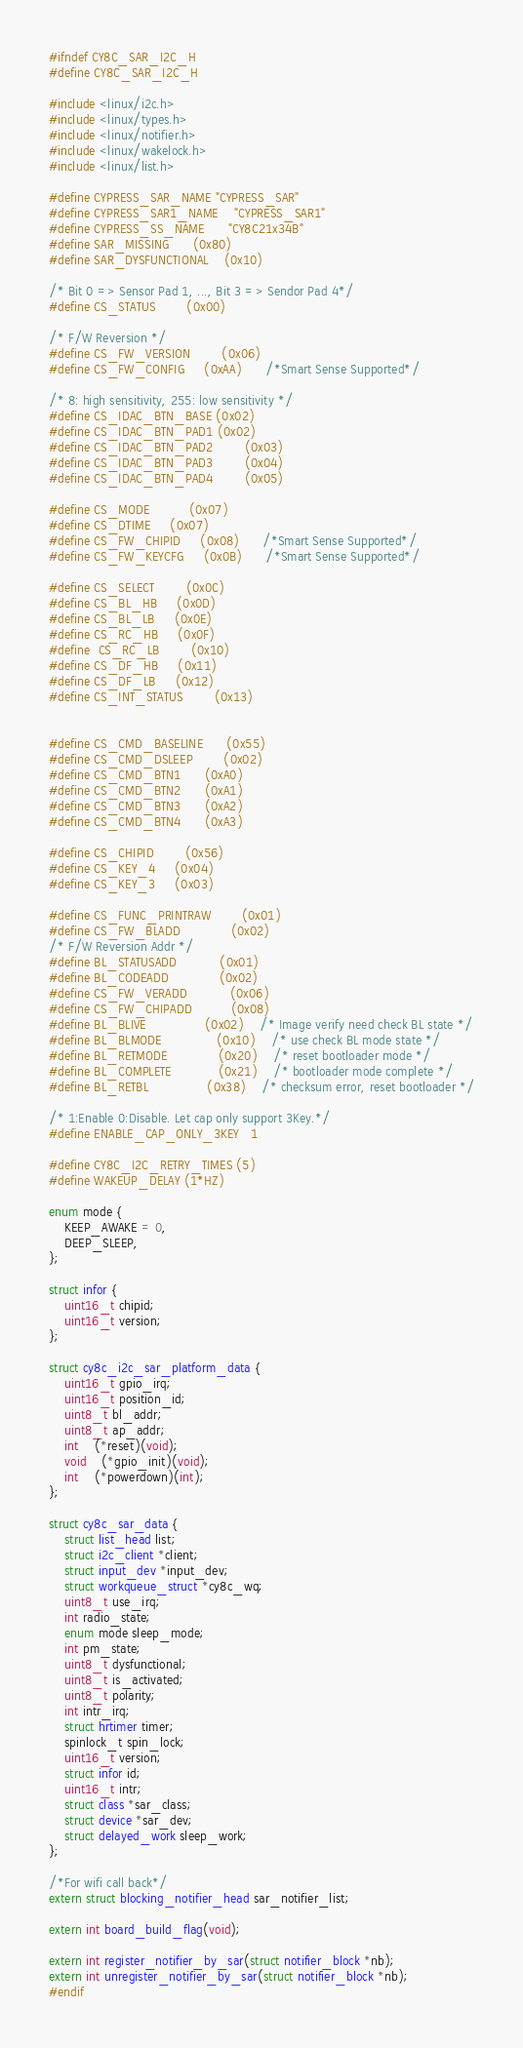Convert code to text. <code><loc_0><loc_0><loc_500><loc_500><_C_>#ifndef CY8C_SAR_I2C_H
#define CY8C_SAR_I2C_H

#include <linux/i2c.h>
#include <linux/types.h>
#include <linux/notifier.h>
#include <linux/wakelock.h>
#include <linux/list.h>

#define CYPRESS_SAR_NAME	"CYPRESS_SAR"
#define CYPRESS_SAR1_NAME	"CYPRESS_SAR1"
#define CYPRESS_SS_NAME		"CY8C21x34B"
#define SAR_MISSING		(0x80)
#define SAR_DYSFUNCTIONAL	(0x10)

/* Bit 0 => Sensor Pad 1, ..., Bit 3 => Sendor Pad 4*/
#define CS_STATUS		(0x00)

/* F/W Reversion */
#define CS_FW_VERSION		(0x06)
#define CS_FW_CONFIG		(0xAA)		/*Smart Sense Supported*/

/* 8: high sensitivity, 255: low sensitivity */
#define CS_IDAC_BTN_BASE	(0x02)
#define CS_IDAC_BTN_PAD1	(0x02)
#define CS_IDAC_BTN_PAD2        (0x03)
#define CS_IDAC_BTN_PAD3        (0x04)
#define CS_IDAC_BTN_PAD4        (0x05)

#define CS_MODE			(0x07)
#define CS_DTIME		(0x07)
#define CS_FW_CHIPID		(0x08)		/*Smart Sense Supported*/
#define CS_FW_KEYCFG		(0x0B)		/*Smart Sense Supported*/

#define CS_SELECT		(0x0C)
#define CS_BL_HB		(0x0D)
#define CS_BL_LB		(0x0E)
#define CS_RC_HB		(0x0F)
#define	CS_RC_LB		(0x10)
#define CS_DF_HB		(0x11)
#define CS_DF_LB		(0x12)
#define CS_INT_STATUS		(0x13)


#define CS_CMD_BASELINE		(0x55)
#define CS_CMD_DSLEEP		(0x02)
#define CS_CMD_BTN1		(0xA0)
#define CS_CMD_BTN2		(0xA1)
#define CS_CMD_BTN3		(0xA2)
#define CS_CMD_BTN4		(0xA3)

#define CS_CHIPID		(0x56)
#define CS_KEY_4		(0x04)
#define CS_KEY_3		(0x03)

#define CS_FUNC_PRINTRAW        (0x01)
#define CS_FW_BLADD             (0x02)
/* F/W Reversion Addr */
#define BL_STATUSADD           (0x01)
#define BL_CODEADD             (0x02)
#define CS_FW_VERADD           (0x06)
#define CS_FW_CHIPADD          (0x08)
#define BL_BLIVE               (0x02)	/* Image verify need check BL state */
#define BL_BLMODE              (0x10)	/* use check BL mode state */
#define BL_RETMODE             (0x20)	/* reset bootloader mode */
#define BL_COMPLETE            (0x21)	/* bootloader mode complete */
#define BL_RETBL               (0x38)	/* checksum error, reset bootloader */

/* 1:Enable 0:Disable. Let cap only support 3Key.*/
#define ENABLE_CAP_ONLY_3KEY   1

#define CY8C_I2C_RETRY_TIMES	(5)
#define WAKEUP_DELAY (1*HZ)

enum mode {
	KEEP_AWAKE = 0,
	DEEP_SLEEP,
};

struct infor {
	uint16_t chipid;
	uint16_t version;
};

struct cy8c_i2c_sar_platform_data {
	uint16_t gpio_irq;
	uint16_t position_id;
	uint8_t bl_addr;
	uint8_t ap_addr;
	int	(*reset)(void);
	void	(*gpio_init)(void);
	int	(*powerdown)(int);
};

struct cy8c_sar_data {
	struct list_head list;
	struct i2c_client *client;
	struct input_dev *input_dev;
	struct workqueue_struct *cy8c_wq;
	uint8_t use_irq;
	int radio_state;
	enum mode sleep_mode;
	int pm_state;
	uint8_t dysfunctional;
	uint8_t is_activated;
	uint8_t polarity;
	int intr_irq;
	struct hrtimer timer;
	spinlock_t spin_lock;
	uint16_t version;
	struct infor id;
	uint16_t intr;
	struct class *sar_class;
	struct device *sar_dev;
	struct delayed_work sleep_work;
};

/*For wifi call back*/
extern struct blocking_notifier_head sar_notifier_list;

extern int board_build_flag(void);

extern int register_notifier_by_sar(struct notifier_block *nb);
extern int unregister_notifier_by_sar(struct notifier_block *nb);
#endif
</code> 